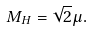Convert formula to latex. <formula><loc_0><loc_0><loc_500><loc_500>M _ { H } = \sqrt { 2 } \mu .</formula> 